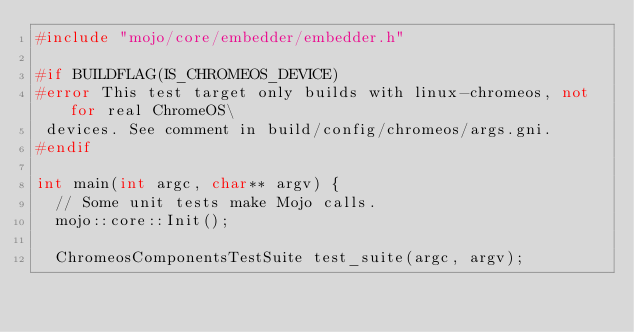<code> <loc_0><loc_0><loc_500><loc_500><_C++_>#include "mojo/core/embedder/embedder.h"

#if BUILDFLAG(IS_CHROMEOS_DEVICE)
#error This test target only builds with linux-chromeos, not for real ChromeOS\
 devices. See comment in build/config/chromeos/args.gni.
#endif

int main(int argc, char** argv) {
  // Some unit tests make Mojo calls.
  mojo::core::Init();

  ChromeosComponentsTestSuite test_suite(argc, argv);</code> 